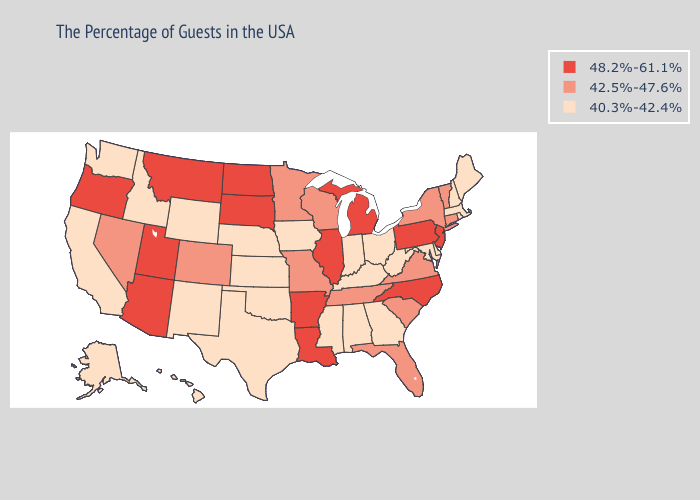Among the states that border Kansas , which have the highest value?
Answer briefly. Missouri, Colorado. Does Colorado have a lower value than Minnesota?
Answer briefly. No. Among the states that border Virginia , which have the highest value?
Keep it brief. North Carolina. What is the value of Washington?
Answer briefly. 40.3%-42.4%. What is the value of Connecticut?
Quick response, please. 42.5%-47.6%. Name the states that have a value in the range 48.2%-61.1%?
Quick response, please. New Jersey, Pennsylvania, North Carolina, Michigan, Illinois, Louisiana, Arkansas, South Dakota, North Dakota, Utah, Montana, Arizona, Oregon. Is the legend a continuous bar?
Answer briefly. No. What is the value of Michigan?
Concise answer only. 48.2%-61.1%. Name the states that have a value in the range 42.5%-47.6%?
Answer briefly. Vermont, Connecticut, New York, Virginia, South Carolina, Florida, Tennessee, Wisconsin, Missouri, Minnesota, Colorado, Nevada. What is the lowest value in the MidWest?
Give a very brief answer. 40.3%-42.4%. Name the states that have a value in the range 40.3%-42.4%?
Answer briefly. Maine, Massachusetts, Rhode Island, New Hampshire, Delaware, Maryland, West Virginia, Ohio, Georgia, Kentucky, Indiana, Alabama, Mississippi, Iowa, Kansas, Nebraska, Oklahoma, Texas, Wyoming, New Mexico, Idaho, California, Washington, Alaska, Hawaii. Among the states that border Indiana , does Kentucky have the highest value?
Write a very short answer. No. What is the value of Pennsylvania?
Write a very short answer. 48.2%-61.1%. Does Utah have a higher value than Indiana?
Be succinct. Yes. 